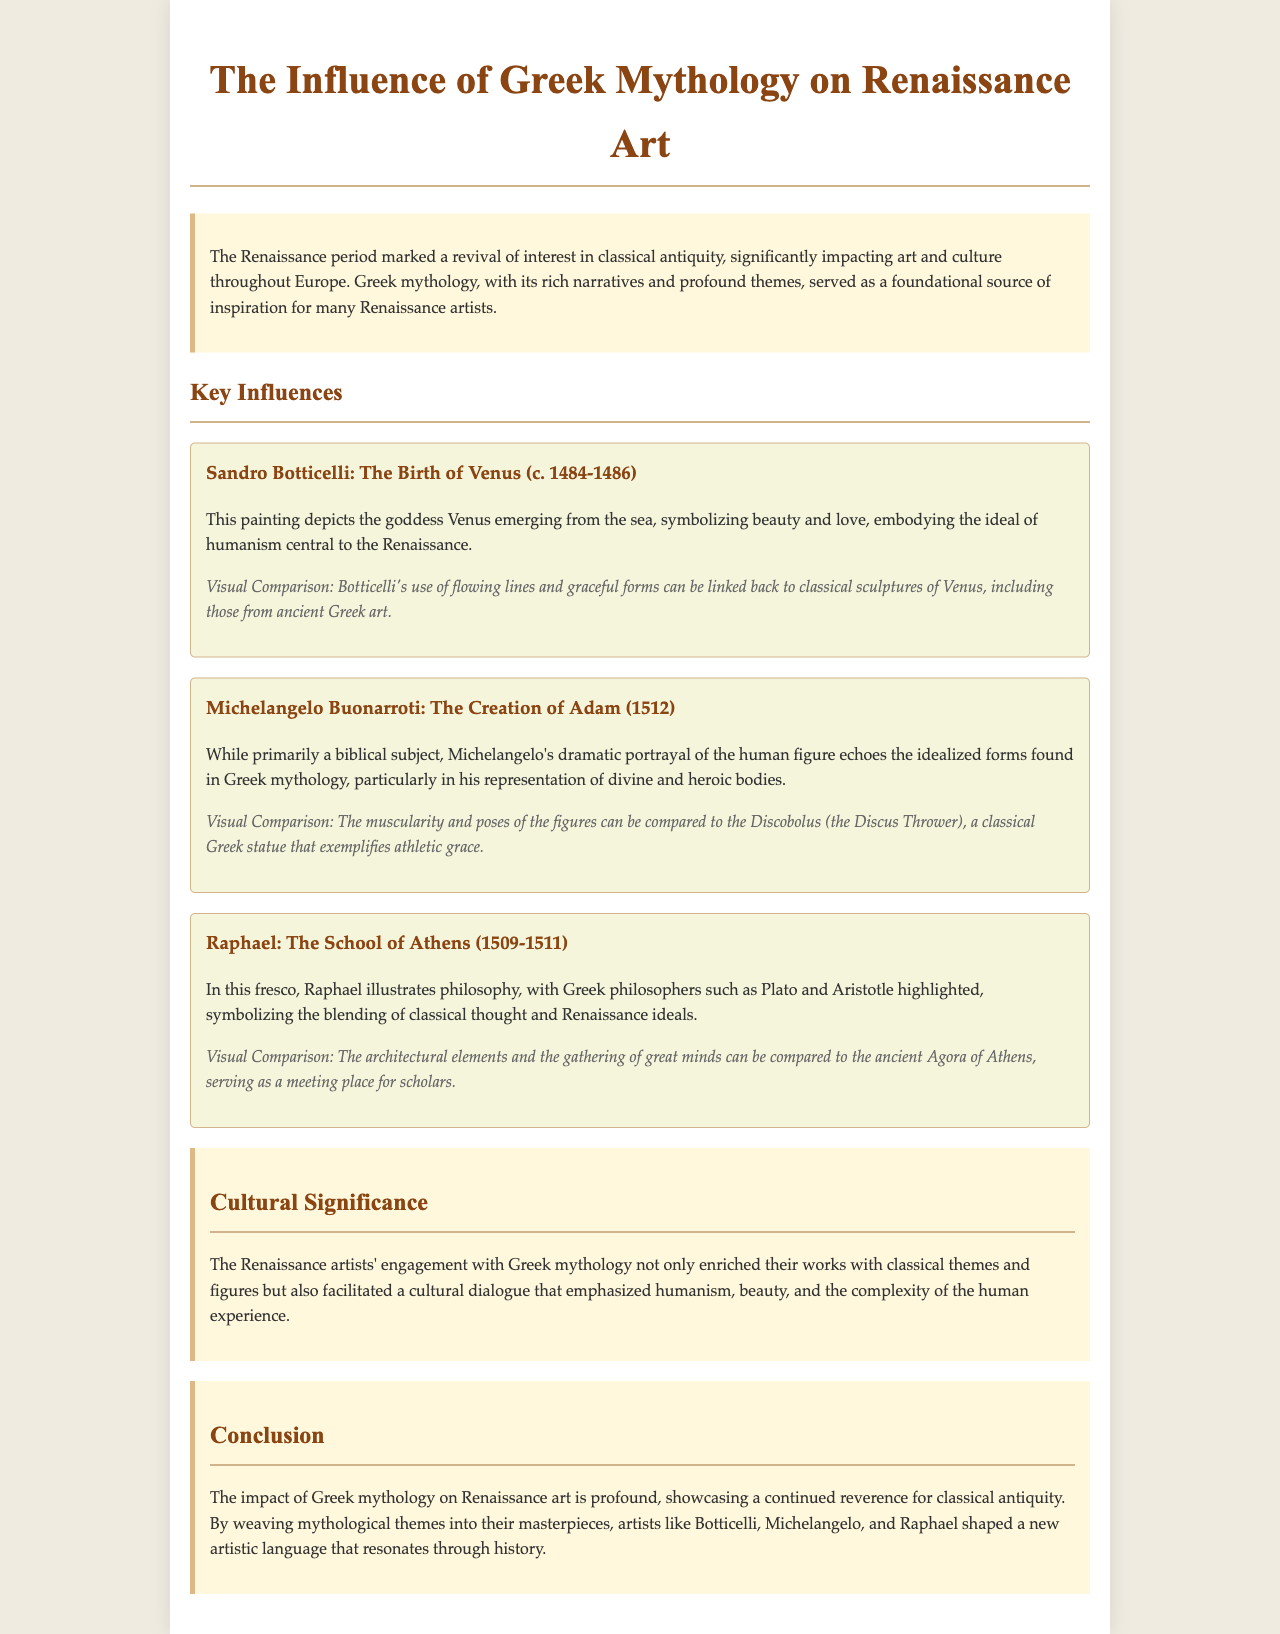What is the title of the report? The title of the report is mentioned at the beginning of the document.
Answer: The Influence of Greek Mythology on Renaissance Art Who painted The Birth of Venus? The artist who created The Birth of Venus is noted in the section describing this artwork.
Answer: Sandro Botticelli What year was The Creation of Adam completed? The completion year of The Creation of Adam is provided in the document.
Answer: 1512 Which two Greek philosophers are highlighted in The School of Athens? The document specifies key figures depicted in Raphael's fresco.
Answer: Plato and Aristotle What cultural movement is emphasized by the Renaissance artists' engagement with Greek mythology? The document discusses the broader themes influenced by Greek mythology in Renaissance art.
Answer: Humanism How does Michelangelo's work relate to Greek ideals? The document explains how Michelangelo’s portrayal aligns with classical representations.
Answer: Idealized forms What is the primary subject of Raphael's The School of Athens? The document indicates the main theme illustrated in this fresco.
Answer: Philosophy What elements does the document use to visually compare Botticelli's painting? The comparison section for Botticelli describes specific visual characteristics linked to classical art.
Answer: Flowing lines and graceful forms 